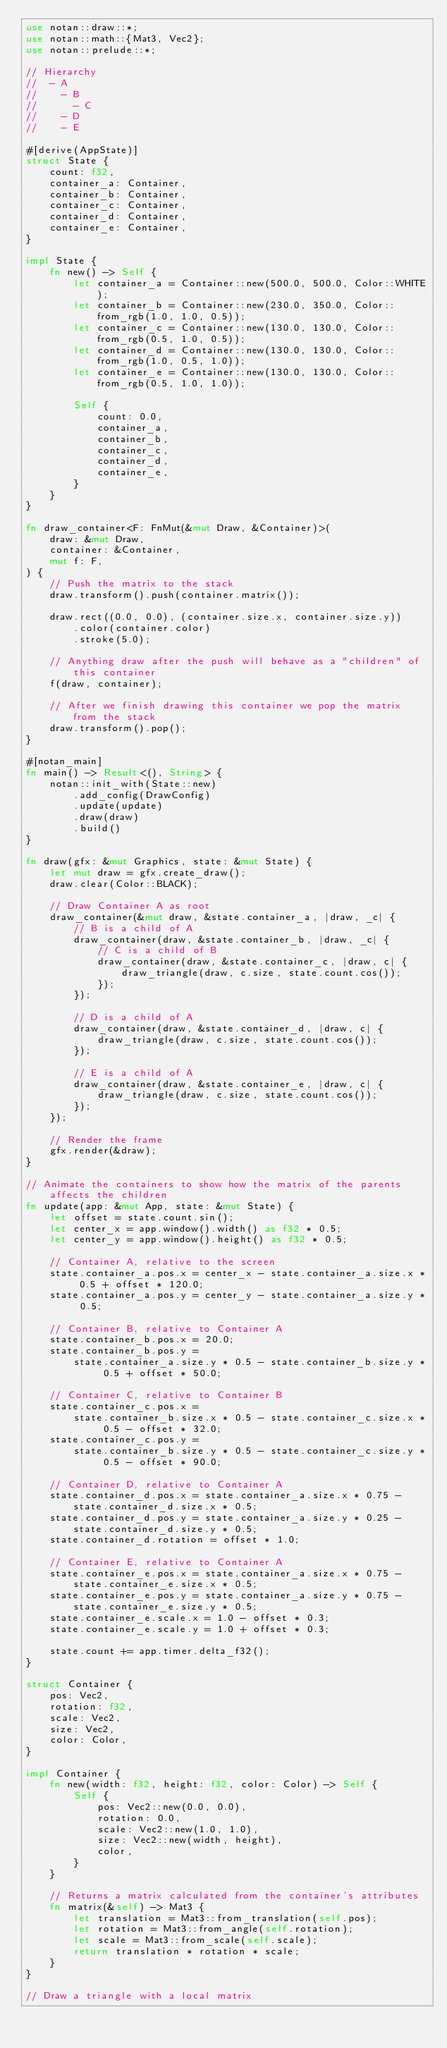<code> <loc_0><loc_0><loc_500><loc_500><_Rust_>use notan::draw::*;
use notan::math::{Mat3, Vec2};
use notan::prelude::*;

// Hierarchy
//  - A
//    - B
//      - C
//    - D
//    - E

#[derive(AppState)]
struct State {
    count: f32,
    container_a: Container,
    container_b: Container,
    container_c: Container,
    container_d: Container,
    container_e: Container,
}

impl State {
    fn new() -> Self {
        let container_a = Container::new(500.0, 500.0, Color::WHITE);
        let container_b = Container::new(230.0, 350.0, Color::from_rgb(1.0, 1.0, 0.5));
        let container_c = Container::new(130.0, 130.0, Color::from_rgb(0.5, 1.0, 0.5));
        let container_d = Container::new(130.0, 130.0, Color::from_rgb(1.0, 0.5, 1.0));
        let container_e = Container::new(130.0, 130.0, Color::from_rgb(0.5, 1.0, 1.0));

        Self {
            count: 0.0,
            container_a,
            container_b,
            container_c,
            container_d,
            container_e,
        }
    }
}

fn draw_container<F: FnMut(&mut Draw, &Container)>(
    draw: &mut Draw,
    container: &Container,
    mut f: F,
) {
    // Push the matrix to the stack
    draw.transform().push(container.matrix());

    draw.rect((0.0, 0.0), (container.size.x, container.size.y))
        .color(container.color)
        .stroke(5.0);

    // Anything draw after the push will behave as a "children" of this container
    f(draw, container);

    // After we finish drawing this container we pop the matrix from the stack
    draw.transform().pop();
}

#[notan_main]
fn main() -> Result<(), String> {
    notan::init_with(State::new)
        .add_config(DrawConfig)
        .update(update)
        .draw(draw)
        .build()
}

fn draw(gfx: &mut Graphics, state: &mut State) {
    let mut draw = gfx.create_draw();
    draw.clear(Color::BLACK);

    // Draw Container A as root
    draw_container(&mut draw, &state.container_a, |draw, _c| {
        // B is a child of A
        draw_container(draw, &state.container_b, |draw, _c| {
            // C is a child of B
            draw_container(draw, &state.container_c, |draw, c| {
                draw_triangle(draw, c.size, state.count.cos());
            });
        });

        // D is a child of A
        draw_container(draw, &state.container_d, |draw, c| {
            draw_triangle(draw, c.size, state.count.cos());
        });

        // E is a child of A
        draw_container(draw, &state.container_e, |draw, c| {
            draw_triangle(draw, c.size, state.count.cos());
        });
    });

    // Render the frame
    gfx.render(&draw);
}

// Animate the containers to show how the matrix of the parents affects the children
fn update(app: &mut App, state: &mut State) {
    let offset = state.count.sin();
    let center_x = app.window().width() as f32 * 0.5;
    let center_y = app.window().height() as f32 * 0.5;

    // Container A, relative to the screen
    state.container_a.pos.x = center_x - state.container_a.size.x * 0.5 + offset * 120.0;
    state.container_a.pos.y = center_y - state.container_a.size.y * 0.5;

    // Container B, relative to Container A
    state.container_b.pos.x = 20.0;
    state.container_b.pos.y =
        state.container_a.size.y * 0.5 - state.container_b.size.y * 0.5 + offset * 50.0;

    // Container C, relative to Container B
    state.container_c.pos.x =
        state.container_b.size.x * 0.5 - state.container_c.size.x * 0.5 - offset * 32.0;
    state.container_c.pos.y =
        state.container_b.size.y * 0.5 - state.container_c.size.y * 0.5 - offset * 90.0;

    // Container D, relative to Container A
    state.container_d.pos.x = state.container_a.size.x * 0.75 - state.container_d.size.x * 0.5;
    state.container_d.pos.y = state.container_a.size.y * 0.25 - state.container_d.size.y * 0.5;
    state.container_d.rotation = offset * 1.0;

    // Container E, relative to Container A
    state.container_e.pos.x = state.container_a.size.x * 0.75 - state.container_e.size.x * 0.5;
    state.container_e.pos.y = state.container_a.size.y * 0.75 - state.container_e.size.y * 0.5;
    state.container_e.scale.x = 1.0 - offset * 0.3;
    state.container_e.scale.y = 1.0 + offset * 0.3;

    state.count += app.timer.delta_f32();
}

struct Container {
    pos: Vec2,
    rotation: f32,
    scale: Vec2,
    size: Vec2,
    color: Color,
}

impl Container {
    fn new(width: f32, height: f32, color: Color) -> Self {
        Self {
            pos: Vec2::new(0.0, 0.0),
            rotation: 0.0,
            scale: Vec2::new(1.0, 1.0),
            size: Vec2::new(width, height),
            color,
        }
    }

    // Returns a matrix calculated from the container's attributes
    fn matrix(&self) -> Mat3 {
        let translation = Mat3::from_translation(self.pos);
        let rotation = Mat3::from_angle(self.rotation);
        let scale = Mat3::from_scale(self.scale);
        return translation * rotation * scale;
    }
}

// Draw a triangle with a local matrix</code> 